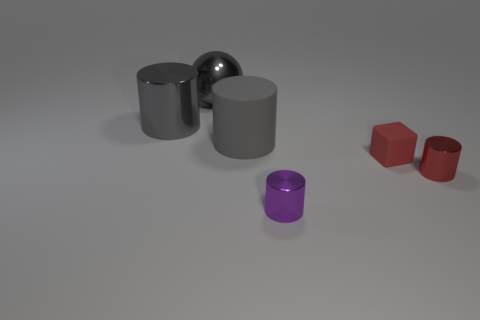Can you tell me what's different about the two red objects compared to the others? Certainly, the two red objects are distinct because they are colored red, unlike the rest, which are gray, silver or purple. They also have a matte finish, rather than a reflective one, and their shapes are unique as well— one is a hexagon and the other is a hollow cylinder.  What could be the possible use of these objects, any thoughts? These objects appear to be representative models, possibly used for educational or decorative purposes. Given their various shapes and materials, they could also serve as parts of a learning kit to teach about geometry, material properties, or even photography composition. 